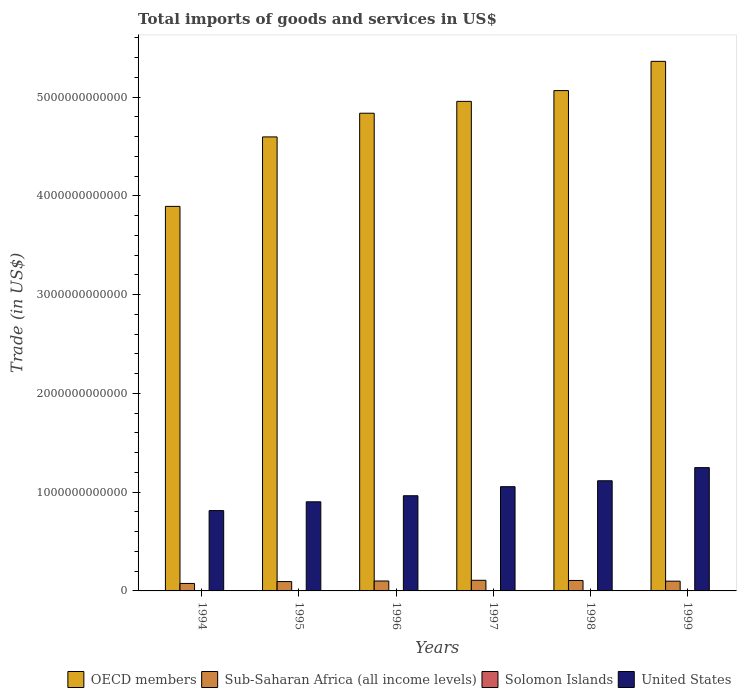Are the number of bars per tick equal to the number of legend labels?
Offer a very short reply. Yes. Are the number of bars on each tick of the X-axis equal?
Your response must be concise. Yes. What is the total imports of goods and services in Sub-Saharan Africa (all income levels) in 1994?
Provide a short and direct response. 7.58e+1. Across all years, what is the maximum total imports of goods and services in Solomon Islands?
Provide a short and direct response. 3.72e+08. Across all years, what is the minimum total imports of goods and services in OECD members?
Offer a very short reply. 3.89e+12. In which year was the total imports of goods and services in Solomon Islands maximum?
Make the answer very short. 1997. What is the total total imports of goods and services in Solomon Islands in the graph?
Make the answer very short. 1.76e+09. What is the difference between the total imports of goods and services in Solomon Islands in 1994 and that in 1997?
Provide a succinct answer. -5.29e+07. What is the difference between the total imports of goods and services in Sub-Saharan Africa (all income levels) in 1998 and the total imports of goods and services in United States in 1996?
Your answer should be very brief. -8.58e+11. What is the average total imports of goods and services in OECD members per year?
Keep it short and to the point. 4.79e+12. In the year 1994, what is the difference between the total imports of goods and services in United States and total imports of goods and services in Sub-Saharan Africa (all income levels)?
Keep it short and to the point. 7.38e+11. What is the ratio of the total imports of goods and services in OECD members in 1998 to that in 1999?
Your answer should be compact. 0.94. Is the difference between the total imports of goods and services in United States in 1994 and 1998 greater than the difference between the total imports of goods and services in Sub-Saharan Africa (all income levels) in 1994 and 1998?
Give a very brief answer. No. What is the difference between the highest and the second highest total imports of goods and services in United States?
Make the answer very short. 1.33e+11. What is the difference between the highest and the lowest total imports of goods and services in Sub-Saharan Africa (all income levels)?
Your response must be concise. 3.19e+1. What does the 3rd bar from the left in 1997 represents?
Make the answer very short. Solomon Islands. Is it the case that in every year, the sum of the total imports of goods and services in OECD members and total imports of goods and services in United States is greater than the total imports of goods and services in Solomon Islands?
Provide a short and direct response. Yes. How many bars are there?
Provide a succinct answer. 24. Are all the bars in the graph horizontal?
Keep it short and to the point. No. What is the difference between two consecutive major ticks on the Y-axis?
Provide a succinct answer. 1.00e+12. Does the graph contain any zero values?
Your response must be concise. No. Does the graph contain grids?
Make the answer very short. No. How many legend labels are there?
Offer a terse response. 4. What is the title of the graph?
Offer a terse response. Total imports of goods and services in US$. What is the label or title of the Y-axis?
Offer a very short reply. Trade (in US$). What is the Trade (in US$) in OECD members in 1994?
Ensure brevity in your answer.  3.89e+12. What is the Trade (in US$) in Sub-Saharan Africa (all income levels) in 1994?
Your answer should be very brief. 7.58e+1. What is the Trade (in US$) in Solomon Islands in 1994?
Your answer should be compact. 3.20e+08. What is the Trade (in US$) of United States in 1994?
Ensure brevity in your answer.  8.13e+11. What is the Trade (in US$) in OECD members in 1995?
Ensure brevity in your answer.  4.60e+12. What is the Trade (in US$) in Sub-Saharan Africa (all income levels) in 1995?
Make the answer very short. 9.47e+1. What is the Trade (in US$) of Solomon Islands in 1995?
Offer a terse response. 3.04e+08. What is the Trade (in US$) in United States in 1995?
Make the answer very short. 9.03e+11. What is the Trade (in US$) of OECD members in 1996?
Give a very brief answer. 4.84e+12. What is the Trade (in US$) of Sub-Saharan Africa (all income levels) in 1996?
Your response must be concise. 1.01e+11. What is the Trade (in US$) in Solomon Islands in 1996?
Offer a very short reply. 3.15e+08. What is the Trade (in US$) of United States in 1996?
Give a very brief answer. 9.64e+11. What is the Trade (in US$) in OECD members in 1997?
Make the answer very short. 4.96e+12. What is the Trade (in US$) in Sub-Saharan Africa (all income levels) in 1997?
Offer a very short reply. 1.08e+11. What is the Trade (in US$) in Solomon Islands in 1997?
Give a very brief answer. 3.72e+08. What is the Trade (in US$) of United States in 1997?
Offer a terse response. 1.06e+12. What is the Trade (in US$) of OECD members in 1998?
Provide a short and direct response. 5.07e+12. What is the Trade (in US$) in Sub-Saharan Africa (all income levels) in 1998?
Offer a very short reply. 1.06e+11. What is the Trade (in US$) in Solomon Islands in 1998?
Your response must be concise. 2.48e+08. What is the Trade (in US$) of United States in 1998?
Your answer should be compact. 1.12e+12. What is the Trade (in US$) of OECD members in 1999?
Provide a short and direct response. 5.36e+12. What is the Trade (in US$) of Sub-Saharan Africa (all income levels) in 1999?
Offer a terse response. 9.89e+1. What is the Trade (in US$) in Solomon Islands in 1999?
Offer a very short reply. 2.03e+08. What is the Trade (in US$) of United States in 1999?
Your response must be concise. 1.25e+12. Across all years, what is the maximum Trade (in US$) of OECD members?
Give a very brief answer. 5.36e+12. Across all years, what is the maximum Trade (in US$) in Sub-Saharan Africa (all income levels)?
Offer a terse response. 1.08e+11. Across all years, what is the maximum Trade (in US$) of Solomon Islands?
Ensure brevity in your answer.  3.72e+08. Across all years, what is the maximum Trade (in US$) in United States?
Offer a terse response. 1.25e+12. Across all years, what is the minimum Trade (in US$) of OECD members?
Your answer should be compact. 3.89e+12. Across all years, what is the minimum Trade (in US$) of Sub-Saharan Africa (all income levels)?
Your answer should be very brief. 7.58e+1. Across all years, what is the minimum Trade (in US$) in Solomon Islands?
Keep it short and to the point. 2.03e+08. Across all years, what is the minimum Trade (in US$) in United States?
Ensure brevity in your answer.  8.13e+11. What is the total Trade (in US$) in OECD members in the graph?
Make the answer very short. 2.87e+13. What is the total Trade (in US$) in Sub-Saharan Africa (all income levels) in the graph?
Give a very brief answer. 5.83e+11. What is the total Trade (in US$) in Solomon Islands in the graph?
Provide a succinct answer. 1.76e+09. What is the total Trade (in US$) of United States in the graph?
Ensure brevity in your answer.  6.10e+12. What is the difference between the Trade (in US$) of OECD members in 1994 and that in 1995?
Your response must be concise. -7.04e+11. What is the difference between the Trade (in US$) of Sub-Saharan Africa (all income levels) in 1994 and that in 1995?
Provide a short and direct response. -1.89e+1. What is the difference between the Trade (in US$) of Solomon Islands in 1994 and that in 1995?
Ensure brevity in your answer.  1.56e+07. What is the difference between the Trade (in US$) of United States in 1994 and that in 1995?
Provide a succinct answer. -8.91e+1. What is the difference between the Trade (in US$) in OECD members in 1994 and that in 1996?
Your answer should be compact. -9.43e+11. What is the difference between the Trade (in US$) in Sub-Saharan Africa (all income levels) in 1994 and that in 1996?
Make the answer very short. -2.47e+1. What is the difference between the Trade (in US$) in Solomon Islands in 1994 and that in 1996?
Offer a very short reply. 4.20e+06. What is the difference between the Trade (in US$) of United States in 1994 and that in 1996?
Give a very brief answer. -1.51e+11. What is the difference between the Trade (in US$) in OECD members in 1994 and that in 1997?
Your answer should be very brief. -1.06e+12. What is the difference between the Trade (in US$) of Sub-Saharan Africa (all income levels) in 1994 and that in 1997?
Offer a terse response. -3.19e+1. What is the difference between the Trade (in US$) of Solomon Islands in 1994 and that in 1997?
Keep it short and to the point. -5.29e+07. What is the difference between the Trade (in US$) in United States in 1994 and that in 1997?
Ensure brevity in your answer.  -2.42e+11. What is the difference between the Trade (in US$) in OECD members in 1994 and that in 1998?
Offer a terse response. -1.17e+12. What is the difference between the Trade (in US$) in Sub-Saharan Africa (all income levels) in 1994 and that in 1998?
Your answer should be very brief. -3.01e+1. What is the difference between the Trade (in US$) in Solomon Islands in 1994 and that in 1998?
Give a very brief answer. 7.14e+07. What is the difference between the Trade (in US$) of United States in 1994 and that in 1998?
Your response must be concise. -3.02e+11. What is the difference between the Trade (in US$) of OECD members in 1994 and that in 1999?
Provide a short and direct response. -1.47e+12. What is the difference between the Trade (in US$) in Sub-Saharan Africa (all income levels) in 1994 and that in 1999?
Ensure brevity in your answer.  -2.31e+1. What is the difference between the Trade (in US$) in Solomon Islands in 1994 and that in 1999?
Your answer should be very brief. 1.17e+08. What is the difference between the Trade (in US$) in United States in 1994 and that in 1999?
Offer a very short reply. -4.35e+11. What is the difference between the Trade (in US$) in OECD members in 1995 and that in 1996?
Keep it short and to the point. -2.40e+11. What is the difference between the Trade (in US$) of Sub-Saharan Africa (all income levels) in 1995 and that in 1996?
Offer a very short reply. -5.80e+09. What is the difference between the Trade (in US$) of Solomon Islands in 1995 and that in 1996?
Provide a short and direct response. -1.14e+07. What is the difference between the Trade (in US$) in United States in 1995 and that in 1996?
Your answer should be compact. -6.14e+1. What is the difference between the Trade (in US$) in OECD members in 1995 and that in 1997?
Keep it short and to the point. -3.60e+11. What is the difference between the Trade (in US$) in Sub-Saharan Africa (all income levels) in 1995 and that in 1997?
Your response must be concise. -1.30e+1. What is the difference between the Trade (in US$) in Solomon Islands in 1995 and that in 1997?
Make the answer very short. -6.85e+07. What is the difference between the Trade (in US$) in United States in 1995 and that in 1997?
Offer a very short reply. -1.53e+11. What is the difference between the Trade (in US$) of OECD members in 1995 and that in 1998?
Your response must be concise. -4.69e+11. What is the difference between the Trade (in US$) of Sub-Saharan Africa (all income levels) in 1995 and that in 1998?
Your response must be concise. -1.12e+1. What is the difference between the Trade (in US$) of Solomon Islands in 1995 and that in 1998?
Keep it short and to the point. 5.58e+07. What is the difference between the Trade (in US$) of United States in 1995 and that in 1998?
Offer a terse response. -2.13e+11. What is the difference between the Trade (in US$) in OECD members in 1995 and that in 1999?
Your answer should be compact. -7.65e+11. What is the difference between the Trade (in US$) of Sub-Saharan Africa (all income levels) in 1995 and that in 1999?
Give a very brief answer. -4.15e+09. What is the difference between the Trade (in US$) in Solomon Islands in 1995 and that in 1999?
Your answer should be very brief. 1.01e+08. What is the difference between the Trade (in US$) in United States in 1995 and that in 1999?
Offer a very short reply. -3.46e+11. What is the difference between the Trade (in US$) in OECD members in 1996 and that in 1997?
Provide a succinct answer. -1.20e+11. What is the difference between the Trade (in US$) of Sub-Saharan Africa (all income levels) in 1996 and that in 1997?
Give a very brief answer. -7.20e+09. What is the difference between the Trade (in US$) in Solomon Islands in 1996 and that in 1997?
Provide a succinct answer. -5.71e+07. What is the difference between the Trade (in US$) in United States in 1996 and that in 1997?
Offer a terse response. -9.18e+1. What is the difference between the Trade (in US$) in OECD members in 1996 and that in 1998?
Your answer should be very brief. -2.29e+11. What is the difference between the Trade (in US$) in Sub-Saharan Africa (all income levels) in 1996 and that in 1998?
Keep it short and to the point. -5.39e+09. What is the difference between the Trade (in US$) of Solomon Islands in 1996 and that in 1998?
Your answer should be very brief. 6.72e+07. What is the difference between the Trade (in US$) of United States in 1996 and that in 1998?
Provide a short and direct response. -1.52e+11. What is the difference between the Trade (in US$) of OECD members in 1996 and that in 1999?
Make the answer very short. -5.25e+11. What is the difference between the Trade (in US$) of Sub-Saharan Africa (all income levels) in 1996 and that in 1999?
Provide a short and direct response. 1.65e+09. What is the difference between the Trade (in US$) in Solomon Islands in 1996 and that in 1999?
Provide a succinct answer. 1.12e+08. What is the difference between the Trade (in US$) of United States in 1996 and that in 1999?
Keep it short and to the point. -2.85e+11. What is the difference between the Trade (in US$) in OECD members in 1997 and that in 1998?
Give a very brief answer. -1.09e+11. What is the difference between the Trade (in US$) in Sub-Saharan Africa (all income levels) in 1997 and that in 1998?
Ensure brevity in your answer.  1.81e+09. What is the difference between the Trade (in US$) in Solomon Islands in 1997 and that in 1998?
Offer a very short reply. 1.24e+08. What is the difference between the Trade (in US$) of United States in 1997 and that in 1998?
Your answer should be very brief. -5.99e+1. What is the difference between the Trade (in US$) in OECD members in 1997 and that in 1999?
Give a very brief answer. -4.05e+11. What is the difference between the Trade (in US$) of Sub-Saharan Africa (all income levels) in 1997 and that in 1999?
Your answer should be very brief. 8.85e+09. What is the difference between the Trade (in US$) in Solomon Islands in 1997 and that in 1999?
Offer a terse response. 1.69e+08. What is the difference between the Trade (in US$) in United States in 1997 and that in 1999?
Offer a very short reply. -1.93e+11. What is the difference between the Trade (in US$) in OECD members in 1998 and that in 1999?
Provide a short and direct response. -2.96e+11. What is the difference between the Trade (in US$) in Sub-Saharan Africa (all income levels) in 1998 and that in 1999?
Your answer should be compact. 7.04e+09. What is the difference between the Trade (in US$) in Solomon Islands in 1998 and that in 1999?
Your response must be concise. 4.51e+07. What is the difference between the Trade (in US$) in United States in 1998 and that in 1999?
Ensure brevity in your answer.  -1.33e+11. What is the difference between the Trade (in US$) in OECD members in 1994 and the Trade (in US$) in Sub-Saharan Africa (all income levels) in 1995?
Your answer should be compact. 3.80e+12. What is the difference between the Trade (in US$) in OECD members in 1994 and the Trade (in US$) in Solomon Islands in 1995?
Offer a terse response. 3.89e+12. What is the difference between the Trade (in US$) in OECD members in 1994 and the Trade (in US$) in United States in 1995?
Provide a succinct answer. 2.99e+12. What is the difference between the Trade (in US$) in Sub-Saharan Africa (all income levels) in 1994 and the Trade (in US$) in Solomon Islands in 1995?
Make the answer very short. 7.55e+1. What is the difference between the Trade (in US$) of Sub-Saharan Africa (all income levels) in 1994 and the Trade (in US$) of United States in 1995?
Your answer should be compact. -8.27e+11. What is the difference between the Trade (in US$) in Solomon Islands in 1994 and the Trade (in US$) in United States in 1995?
Offer a terse response. -9.02e+11. What is the difference between the Trade (in US$) in OECD members in 1994 and the Trade (in US$) in Sub-Saharan Africa (all income levels) in 1996?
Your answer should be compact. 3.79e+12. What is the difference between the Trade (in US$) of OECD members in 1994 and the Trade (in US$) of Solomon Islands in 1996?
Offer a terse response. 3.89e+12. What is the difference between the Trade (in US$) in OECD members in 1994 and the Trade (in US$) in United States in 1996?
Ensure brevity in your answer.  2.93e+12. What is the difference between the Trade (in US$) of Sub-Saharan Africa (all income levels) in 1994 and the Trade (in US$) of Solomon Islands in 1996?
Make the answer very short. 7.55e+1. What is the difference between the Trade (in US$) of Sub-Saharan Africa (all income levels) in 1994 and the Trade (in US$) of United States in 1996?
Make the answer very short. -8.88e+11. What is the difference between the Trade (in US$) in Solomon Islands in 1994 and the Trade (in US$) in United States in 1996?
Ensure brevity in your answer.  -9.64e+11. What is the difference between the Trade (in US$) in OECD members in 1994 and the Trade (in US$) in Sub-Saharan Africa (all income levels) in 1997?
Give a very brief answer. 3.79e+12. What is the difference between the Trade (in US$) in OECD members in 1994 and the Trade (in US$) in Solomon Islands in 1997?
Ensure brevity in your answer.  3.89e+12. What is the difference between the Trade (in US$) of OECD members in 1994 and the Trade (in US$) of United States in 1997?
Your response must be concise. 2.84e+12. What is the difference between the Trade (in US$) in Sub-Saharan Africa (all income levels) in 1994 and the Trade (in US$) in Solomon Islands in 1997?
Give a very brief answer. 7.54e+1. What is the difference between the Trade (in US$) of Sub-Saharan Africa (all income levels) in 1994 and the Trade (in US$) of United States in 1997?
Offer a very short reply. -9.80e+11. What is the difference between the Trade (in US$) of Solomon Islands in 1994 and the Trade (in US$) of United States in 1997?
Give a very brief answer. -1.06e+12. What is the difference between the Trade (in US$) in OECD members in 1994 and the Trade (in US$) in Sub-Saharan Africa (all income levels) in 1998?
Your answer should be compact. 3.79e+12. What is the difference between the Trade (in US$) of OECD members in 1994 and the Trade (in US$) of Solomon Islands in 1998?
Your answer should be very brief. 3.89e+12. What is the difference between the Trade (in US$) in OECD members in 1994 and the Trade (in US$) in United States in 1998?
Your answer should be compact. 2.78e+12. What is the difference between the Trade (in US$) of Sub-Saharan Africa (all income levels) in 1994 and the Trade (in US$) of Solomon Islands in 1998?
Keep it short and to the point. 7.55e+1. What is the difference between the Trade (in US$) of Sub-Saharan Africa (all income levels) in 1994 and the Trade (in US$) of United States in 1998?
Ensure brevity in your answer.  -1.04e+12. What is the difference between the Trade (in US$) of Solomon Islands in 1994 and the Trade (in US$) of United States in 1998?
Your answer should be compact. -1.12e+12. What is the difference between the Trade (in US$) in OECD members in 1994 and the Trade (in US$) in Sub-Saharan Africa (all income levels) in 1999?
Provide a succinct answer. 3.80e+12. What is the difference between the Trade (in US$) of OECD members in 1994 and the Trade (in US$) of Solomon Islands in 1999?
Ensure brevity in your answer.  3.89e+12. What is the difference between the Trade (in US$) of OECD members in 1994 and the Trade (in US$) of United States in 1999?
Provide a short and direct response. 2.65e+12. What is the difference between the Trade (in US$) in Sub-Saharan Africa (all income levels) in 1994 and the Trade (in US$) in Solomon Islands in 1999?
Provide a succinct answer. 7.56e+1. What is the difference between the Trade (in US$) in Sub-Saharan Africa (all income levels) in 1994 and the Trade (in US$) in United States in 1999?
Offer a very short reply. -1.17e+12. What is the difference between the Trade (in US$) in Solomon Islands in 1994 and the Trade (in US$) in United States in 1999?
Your answer should be very brief. -1.25e+12. What is the difference between the Trade (in US$) of OECD members in 1995 and the Trade (in US$) of Sub-Saharan Africa (all income levels) in 1996?
Offer a terse response. 4.50e+12. What is the difference between the Trade (in US$) of OECD members in 1995 and the Trade (in US$) of Solomon Islands in 1996?
Provide a succinct answer. 4.60e+12. What is the difference between the Trade (in US$) of OECD members in 1995 and the Trade (in US$) of United States in 1996?
Offer a very short reply. 3.63e+12. What is the difference between the Trade (in US$) in Sub-Saharan Africa (all income levels) in 1995 and the Trade (in US$) in Solomon Islands in 1996?
Provide a succinct answer. 9.44e+1. What is the difference between the Trade (in US$) of Sub-Saharan Africa (all income levels) in 1995 and the Trade (in US$) of United States in 1996?
Your response must be concise. -8.69e+11. What is the difference between the Trade (in US$) of Solomon Islands in 1995 and the Trade (in US$) of United States in 1996?
Your answer should be compact. -9.64e+11. What is the difference between the Trade (in US$) of OECD members in 1995 and the Trade (in US$) of Sub-Saharan Africa (all income levels) in 1997?
Your answer should be compact. 4.49e+12. What is the difference between the Trade (in US$) in OECD members in 1995 and the Trade (in US$) in Solomon Islands in 1997?
Give a very brief answer. 4.60e+12. What is the difference between the Trade (in US$) of OECD members in 1995 and the Trade (in US$) of United States in 1997?
Provide a succinct answer. 3.54e+12. What is the difference between the Trade (in US$) of Sub-Saharan Africa (all income levels) in 1995 and the Trade (in US$) of Solomon Islands in 1997?
Make the answer very short. 9.43e+1. What is the difference between the Trade (in US$) in Sub-Saharan Africa (all income levels) in 1995 and the Trade (in US$) in United States in 1997?
Provide a short and direct response. -9.61e+11. What is the difference between the Trade (in US$) in Solomon Islands in 1995 and the Trade (in US$) in United States in 1997?
Your answer should be very brief. -1.06e+12. What is the difference between the Trade (in US$) of OECD members in 1995 and the Trade (in US$) of Sub-Saharan Africa (all income levels) in 1998?
Provide a short and direct response. 4.49e+12. What is the difference between the Trade (in US$) in OECD members in 1995 and the Trade (in US$) in Solomon Islands in 1998?
Ensure brevity in your answer.  4.60e+12. What is the difference between the Trade (in US$) in OECD members in 1995 and the Trade (in US$) in United States in 1998?
Your answer should be compact. 3.48e+12. What is the difference between the Trade (in US$) of Sub-Saharan Africa (all income levels) in 1995 and the Trade (in US$) of Solomon Islands in 1998?
Make the answer very short. 9.45e+1. What is the difference between the Trade (in US$) in Sub-Saharan Africa (all income levels) in 1995 and the Trade (in US$) in United States in 1998?
Make the answer very short. -1.02e+12. What is the difference between the Trade (in US$) in Solomon Islands in 1995 and the Trade (in US$) in United States in 1998?
Give a very brief answer. -1.12e+12. What is the difference between the Trade (in US$) in OECD members in 1995 and the Trade (in US$) in Sub-Saharan Africa (all income levels) in 1999?
Give a very brief answer. 4.50e+12. What is the difference between the Trade (in US$) of OECD members in 1995 and the Trade (in US$) of Solomon Islands in 1999?
Give a very brief answer. 4.60e+12. What is the difference between the Trade (in US$) of OECD members in 1995 and the Trade (in US$) of United States in 1999?
Your answer should be compact. 3.35e+12. What is the difference between the Trade (in US$) of Sub-Saharan Africa (all income levels) in 1995 and the Trade (in US$) of Solomon Islands in 1999?
Keep it short and to the point. 9.45e+1. What is the difference between the Trade (in US$) of Sub-Saharan Africa (all income levels) in 1995 and the Trade (in US$) of United States in 1999?
Your answer should be compact. -1.15e+12. What is the difference between the Trade (in US$) in Solomon Islands in 1995 and the Trade (in US$) in United States in 1999?
Keep it short and to the point. -1.25e+12. What is the difference between the Trade (in US$) in OECD members in 1996 and the Trade (in US$) in Sub-Saharan Africa (all income levels) in 1997?
Your answer should be very brief. 4.73e+12. What is the difference between the Trade (in US$) in OECD members in 1996 and the Trade (in US$) in Solomon Islands in 1997?
Your answer should be compact. 4.84e+12. What is the difference between the Trade (in US$) of OECD members in 1996 and the Trade (in US$) of United States in 1997?
Offer a terse response. 3.78e+12. What is the difference between the Trade (in US$) of Sub-Saharan Africa (all income levels) in 1996 and the Trade (in US$) of Solomon Islands in 1997?
Your response must be concise. 1.00e+11. What is the difference between the Trade (in US$) of Sub-Saharan Africa (all income levels) in 1996 and the Trade (in US$) of United States in 1997?
Provide a short and direct response. -9.55e+11. What is the difference between the Trade (in US$) of Solomon Islands in 1996 and the Trade (in US$) of United States in 1997?
Provide a succinct answer. -1.06e+12. What is the difference between the Trade (in US$) in OECD members in 1996 and the Trade (in US$) in Sub-Saharan Africa (all income levels) in 1998?
Offer a very short reply. 4.73e+12. What is the difference between the Trade (in US$) of OECD members in 1996 and the Trade (in US$) of Solomon Islands in 1998?
Offer a very short reply. 4.84e+12. What is the difference between the Trade (in US$) in OECD members in 1996 and the Trade (in US$) in United States in 1998?
Provide a succinct answer. 3.72e+12. What is the difference between the Trade (in US$) in Sub-Saharan Africa (all income levels) in 1996 and the Trade (in US$) in Solomon Islands in 1998?
Offer a very short reply. 1.00e+11. What is the difference between the Trade (in US$) of Sub-Saharan Africa (all income levels) in 1996 and the Trade (in US$) of United States in 1998?
Make the answer very short. -1.02e+12. What is the difference between the Trade (in US$) of Solomon Islands in 1996 and the Trade (in US$) of United States in 1998?
Your response must be concise. -1.12e+12. What is the difference between the Trade (in US$) in OECD members in 1996 and the Trade (in US$) in Sub-Saharan Africa (all income levels) in 1999?
Give a very brief answer. 4.74e+12. What is the difference between the Trade (in US$) of OECD members in 1996 and the Trade (in US$) of Solomon Islands in 1999?
Provide a short and direct response. 4.84e+12. What is the difference between the Trade (in US$) of OECD members in 1996 and the Trade (in US$) of United States in 1999?
Make the answer very short. 3.59e+12. What is the difference between the Trade (in US$) of Sub-Saharan Africa (all income levels) in 1996 and the Trade (in US$) of Solomon Islands in 1999?
Provide a short and direct response. 1.00e+11. What is the difference between the Trade (in US$) of Sub-Saharan Africa (all income levels) in 1996 and the Trade (in US$) of United States in 1999?
Your response must be concise. -1.15e+12. What is the difference between the Trade (in US$) in Solomon Islands in 1996 and the Trade (in US$) in United States in 1999?
Your answer should be compact. -1.25e+12. What is the difference between the Trade (in US$) of OECD members in 1997 and the Trade (in US$) of Sub-Saharan Africa (all income levels) in 1998?
Your answer should be compact. 4.85e+12. What is the difference between the Trade (in US$) of OECD members in 1997 and the Trade (in US$) of Solomon Islands in 1998?
Keep it short and to the point. 4.96e+12. What is the difference between the Trade (in US$) of OECD members in 1997 and the Trade (in US$) of United States in 1998?
Offer a very short reply. 3.84e+12. What is the difference between the Trade (in US$) in Sub-Saharan Africa (all income levels) in 1997 and the Trade (in US$) in Solomon Islands in 1998?
Offer a terse response. 1.07e+11. What is the difference between the Trade (in US$) of Sub-Saharan Africa (all income levels) in 1997 and the Trade (in US$) of United States in 1998?
Your answer should be very brief. -1.01e+12. What is the difference between the Trade (in US$) in Solomon Islands in 1997 and the Trade (in US$) in United States in 1998?
Offer a very short reply. -1.12e+12. What is the difference between the Trade (in US$) of OECD members in 1997 and the Trade (in US$) of Sub-Saharan Africa (all income levels) in 1999?
Offer a very short reply. 4.86e+12. What is the difference between the Trade (in US$) of OECD members in 1997 and the Trade (in US$) of Solomon Islands in 1999?
Offer a very short reply. 4.96e+12. What is the difference between the Trade (in US$) in OECD members in 1997 and the Trade (in US$) in United States in 1999?
Keep it short and to the point. 3.71e+12. What is the difference between the Trade (in US$) of Sub-Saharan Africa (all income levels) in 1997 and the Trade (in US$) of Solomon Islands in 1999?
Your response must be concise. 1.08e+11. What is the difference between the Trade (in US$) of Sub-Saharan Africa (all income levels) in 1997 and the Trade (in US$) of United States in 1999?
Provide a succinct answer. -1.14e+12. What is the difference between the Trade (in US$) of Solomon Islands in 1997 and the Trade (in US$) of United States in 1999?
Make the answer very short. -1.25e+12. What is the difference between the Trade (in US$) of OECD members in 1998 and the Trade (in US$) of Sub-Saharan Africa (all income levels) in 1999?
Provide a short and direct response. 4.97e+12. What is the difference between the Trade (in US$) in OECD members in 1998 and the Trade (in US$) in Solomon Islands in 1999?
Provide a short and direct response. 5.07e+12. What is the difference between the Trade (in US$) of OECD members in 1998 and the Trade (in US$) of United States in 1999?
Give a very brief answer. 3.82e+12. What is the difference between the Trade (in US$) of Sub-Saharan Africa (all income levels) in 1998 and the Trade (in US$) of Solomon Islands in 1999?
Your response must be concise. 1.06e+11. What is the difference between the Trade (in US$) in Sub-Saharan Africa (all income levels) in 1998 and the Trade (in US$) in United States in 1999?
Offer a very short reply. -1.14e+12. What is the difference between the Trade (in US$) of Solomon Islands in 1998 and the Trade (in US$) of United States in 1999?
Provide a short and direct response. -1.25e+12. What is the average Trade (in US$) of OECD members per year?
Your response must be concise. 4.79e+12. What is the average Trade (in US$) of Sub-Saharan Africa (all income levels) per year?
Your answer should be compact. 9.72e+1. What is the average Trade (in US$) in Solomon Islands per year?
Offer a very short reply. 2.94e+08. What is the average Trade (in US$) of United States per year?
Provide a short and direct response. 1.02e+12. In the year 1994, what is the difference between the Trade (in US$) of OECD members and Trade (in US$) of Sub-Saharan Africa (all income levels)?
Provide a succinct answer. 3.82e+12. In the year 1994, what is the difference between the Trade (in US$) in OECD members and Trade (in US$) in Solomon Islands?
Your answer should be compact. 3.89e+12. In the year 1994, what is the difference between the Trade (in US$) of OECD members and Trade (in US$) of United States?
Give a very brief answer. 3.08e+12. In the year 1994, what is the difference between the Trade (in US$) of Sub-Saharan Africa (all income levels) and Trade (in US$) of Solomon Islands?
Provide a succinct answer. 7.55e+1. In the year 1994, what is the difference between the Trade (in US$) of Sub-Saharan Africa (all income levels) and Trade (in US$) of United States?
Make the answer very short. -7.38e+11. In the year 1994, what is the difference between the Trade (in US$) in Solomon Islands and Trade (in US$) in United States?
Ensure brevity in your answer.  -8.13e+11. In the year 1995, what is the difference between the Trade (in US$) in OECD members and Trade (in US$) in Sub-Saharan Africa (all income levels)?
Offer a very short reply. 4.50e+12. In the year 1995, what is the difference between the Trade (in US$) in OECD members and Trade (in US$) in Solomon Islands?
Provide a succinct answer. 4.60e+12. In the year 1995, what is the difference between the Trade (in US$) in OECD members and Trade (in US$) in United States?
Make the answer very short. 3.70e+12. In the year 1995, what is the difference between the Trade (in US$) in Sub-Saharan Africa (all income levels) and Trade (in US$) in Solomon Islands?
Offer a terse response. 9.44e+1. In the year 1995, what is the difference between the Trade (in US$) in Sub-Saharan Africa (all income levels) and Trade (in US$) in United States?
Ensure brevity in your answer.  -8.08e+11. In the year 1995, what is the difference between the Trade (in US$) of Solomon Islands and Trade (in US$) of United States?
Provide a short and direct response. -9.02e+11. In the year 1996, what is the difference between the Trade (in US$) of OECD members and Trade (in US$) of Sub-Saharan Africa (all income levels)?
Your response must be concise. 4.74e+12. In the year 1996, what is the difference between the Trade (in US$) in OECD members and Trade (in US$) in Solomon Islands?
Offer a very short reply. 4.84e+12. In the year 1996, what is the difference between the Trade (in US$) of OECD members and Trade (in US$) of United States?
Offer a very short reply. 3.87e+12. In the year 1996, what is the difference between the Trade (in US$) of Sub-Saharan Africa (all income levels) and Trade (in US$) of Solomon Islands?
Offer a terse response. 1.00e+11. In the year 1996, what is the difference between the Trade (in US$) of Sub-Saharan Africa (all income levels) and Trade (in US$) of United States?
Keep it short and to the point. -8.63e+11. In the year 1996, what is the difference between the Trade (in US$) in Solomon Islands and Trade (in US$) in United States?
Give a very brief answer. -9.64e+11. In the year 1997, what is the difference between the Trade (in US$) in OECD members and Trade (in US$) in Sub-Saharan Africa (all income levels)?
Provide a succinct answer. 4.85e+12. In the year 1997, what is the difference between the Trade (in US$) in OECD members and Trade (in US$) in Solomon Islands?
Provide a succinct answer. 4.96e+12. In the year 1997, what is the difference between the Trade (in US$) in OECD members and Trade (in US$) in United States?
Keep it short and to the point. 3.90e+12. In the year 1997, what is the difference between the Trade (in US$) of Sub-Saharan Africa (all income levels) and Trade (in US$) of Solomon Islands?
Ensure brevity in your answer.  1.07e+11. In the year 1997, what is the difference between the Trade (in US$) of Sub-Saharan Africa (all income levels) and Trade (in US$) of United States?
Your answer should be compact. -9.48e+11. In the year 1997, what is the difference between the Trade (in US$) of Solomon Islands and Trade (in US$) of United States?
Your answer should be very brief. -1.06e+12. In the year 1998, what is the difference between the Trade (in US$) of OECD members and Trade (in US$) of Sub-Saharan Africa (all income levels)?
Provide a short and direct response. 4.96e+12. In the year 1998, what is the difference between the Trade (in US$) of OECD members and Trade (in US$) of Solomon Islands?
Your answer should be compact. 5.07e+12. In the year 1998, what is the difference between the Trade (in US$) of OECD members and Trade (in US$) of United States?
Your answer should be compact. 3.95e+12. In the year 1998, what is the difference between the Trade (in US$) of Sub-Saharan Africa (all income levels) and Trade (in US$) of Solomon Islands?
Provide a succinct answer. 1.06e+11. In the year 1998, what is the difference between the Trade (in US$) in Sub-Saharan Africa (all income levels) and Trade (in US$) in United States?
Keep it short and to the point. -1.01e+12. In the year 1998, what is the difference between the Trade (in US$) in Solomon Islands and Trade (in US$) in United States?
Provide a succinct answer. -1.12e+12. In the year 1999, what is the difference between the Trade (in US$) of OECD members and Trade (in US$) of Sub-Saharan Africa (all income levels)?
Provide a short and direct response. 5.26e+12. In the year 1999, what is the difference between the Trade (in US$) of OECD members and Trade (in US$) of Solomon Islands?
Keep it short and to the point. 5.36e+12. In the year 1999, what is the difference between the Trade (in US$) in OECD members and Trade (in US$) in United States?
Your answer should be very brief. 4.11e+12. In the year 1999, what is the difference between the Trade (in US$) in Sub-Saharan Africa (all income levels) and Trade (in US$) in Solomon Islands?
Your answer should be very brief. 9.87e+1. In the year 1999, what is the difference between the Trade (in US$) in Sub-Saharan Africa (all income levels) and Trade (in US$) in United States?
Provide a succinct answer. -1.15e+12. In the year 1999, what is the difference between the Trade (in US$) of Solomon Islands and Trade (in US$) of United States?
Your response must be concise. -1.25e+12. What is the ratio of the Trade (in US$) in OECD members in 1994 to that in 1995?
Make the answer very short. 0.85. What is the ratio of the Trade (in US$) in Sub-Saharan Africa (all income levels) in 1994 to that in 1995?
Ensure brevity in your answer.  0.8. What is the ratio of the Trade (in US$) of Solomon Islands in 1994 to that in 1995?
Give a very brief answer. 1.05. What is the ratio of the Trade (in US$) of United States in 1994 to that in 1995?
Your answer should be compact. 0.9. What is the ratio of the Trade (in US$) in OECD members in 1994 to that in 1996?
Ensure brevity in your answer.  0.81. What is the ratio of the Trade (in US$) in Sub-Saharan Africa (all income levels) in 1994 to that in 1996?
Give a very brief answer. 0.75. What is the ratio of the Trade (in US$) in Solomon Islands in 1994 to that in 1996?
Your answer should be very brief. 1.01. What is the ratio of the Trade (in US$) of United States in 1994 to that in 1996?
Provide a succinct answer. 0.84. What is the ratio of the Trade (in US$) in OECD members in 1994 to that in 1997?
Your answer should be very brief. 0.79. What is the ratio of the Trade (in US$) in Sub-Saharan Africa (all income levels) in 1994 to that in 1997?
Provide a short and direct response. 0.7. What is the ratio of the Trade (in US$) in Solomon Islands in 1994 to that in 1997?
Your answer should be compact. 0.86. What is the ratio of the Trade (in US$) of United States in 1994 to that in 1997?
Offer a terse response. 0.77. What is the ratio of the Trade (in US$) of OECD members in 1994 to that in 1998?
Your response must be concise. 0.77. What is the ratio of the Trade (in US$) of Sub-Saharan Africa (all income levels) in 1994 to that in 1998?
Provide a short and direct response. 0.72. What is the ratio of the Trade (in US$) of Solomon Islands in 1994 to that in 1998?
Provide a succinct answer. 1.29. What is the ratio of the Trade (in US$) of United States in 1994 to that in 1998?
Ensure brevity in your answer.  0.73. What is the ratio of the Trade (in US$) of OECD members in 1994 to that in 1999?
Offer a very short reply. 0.73. What is the ratio of the Trade (in US$) in Sub-Saharan Africa (all income levels) in 1994 to that in 1999?
Provide a succinct answer. 0.77. What is the ratio of the Trade (in US$) of Solomon Islands in 1994 to that in 1999?
Make the answer very short. 1.57. What is the ratio of the Trade (in US$) of United States in 1994 to that in 1999?
Offer a terse response. 0.65. What is the ratio of the Trade (in US$) in OECD members in 1995 to that in 1996?
Offer a very short reply. 0.95. What is the ratio of the Trade (in US$) of Sub-Saharan Africa (all income levels) in 1995 to that in 1996?
Make the answer very short. 0.94. What is the ratio of the Trade (in US$) in Solomon Islands in 1995 to that in 1996?
Your answer should be compact. 0.96. What is the ratio of the Trade (in US$) of United States in 1995 to that in 1996?
Ensure brevity in your answer.  0.94. What is the ratio of the Trade (in US$) of OECD members in 1995 to that in 1997?
Ensure brevity in your answer.  0.93. What is the ratio of the Trade (in US$) in Sub-Saharan Africa (all income levels) in 1995 to that in 1997?
Offer a very short reply. 0.88. What is the ratio of the Trade (in US$) in Solomon Islands in 1995 to that in 1997?
Give a very brief answer. 0.82. What is the ratio of the Trade (in US$) of United States in 1995 to that in 1997?
Provide a succinct answer. 0.85. What is the ratio of the Trade (in US$) of OECD members in 1995 to that in 1998?
Offer a very short reply. 0.91. What is the ratio of the Trade (in US$) of Sub-Saharan Africa (all income levels) in 1995 to that in 1998?
Offer a very short reply. 0.89. What is the ratio of the Trade (in US$) of Solomon Islands in 1995 to that in 1998?
Keep it short and to the point. 1.22. What is the ratio of the Trade (in US$) of United States in 1995 to that in 1998?
Your response must be concise. 0.81. What is the ratio of the Trade (in US$) in OECD members in 1995 to that in 1999?
Provide a succinct answer. 0.86. What is the ratio of the Trade (in US$) of Sub-Saharan Africa (all income levels) in 1995 to that in 1999?
Your response must be concise. 0.96. What is the ratio of the Trade (in US$) of Solomon Islands in 1995 to that in 1999?
Your response must be concise. 1.5. What is the ratio of the Trade (in US$) of United States in 1995 to that in 1999?
Provide a short and direct response. 0.72. What is the ratio of the Trade (in US$) in OECD members in 1996 to that in 1997?
Give a very brief answer. 0.98. What is the ratio of the Trade (in US$) in Sub-Saharan Africa (all income levels) in 1996 to that in 1997?
Provide a succinct answer. 0.93. What is the ratio of the Trade (in US$) in Solomon Islands in 1996 to that in 1997?
Your response must be concise. 0.85. What is the ratio of the Trade (in US$) in United States in 1996 to that in 1997?
Keep it short and to the point. 0.91. What is the ratio of the Trade (in US$) in OECD members in 1996 to that in 1998?
Your answer should be very brief. 0.95. What is the ratio of the Trade (in US$) of Sub-Saharan Africa (all income levels) in 1996 to that in 1998?
Give a very brief answer. 0.95. What is the ratio of the Trade (in US$) of Solomon Islands in 1996 to that in 1998?
Offer a terse response. 1.27. What is the ratio of the Trade (in US$) of United States in 1996 to that in 1998?
Keep it short and to the point. 0.86. What is the ratio of the Trade (in US$) of OECD members in 1996 to that in 1999?
Give a very brief answer. 0.9. What is the ratio of the Trade (in US$) in Sub-Saharan Africa (all income levels) in 1996 to that in 1999?
Make the answer very short. 1.02. What is the ratio of the Trade (in US$) of Solomon Islands in 1996 to that in 1999?
Give a very brief answer. 1.55. What is the ratio of the Trade (in US$) of United States in 1996 to that in 1999?
Provide a succinct answer. 0.77. What is the ratio of the Trade (in US$) of OECD members in 1997 to that in 1998?
Your response must be concise. 0.98. What is the ratio of the Trade (in US$) in Sub-Saharan Africa (all income levels) in 1997 to that in 1998?
Provide a succinct answer. 1.02. What is the ratio of the Trade (in US$) in Solomon Islands in 1997 to that in 1998?
Make the answer very short. 1.5. What is the ratio of the Trade (in US$) of United States in 1997 to that in 1998?
Offer a terse response. 0.95. What is the ratio of the Trade (in US$) of OECD members in 1997 to that in 1999?
Ensure brevity in your answer.  0.92. What is the ratio of the Trade (in US$) of Sub-Saharan Africa (all income levels) in 1997 to that in 1999?
Your answer should be compact. 1.09. What is the ratio of the Trade (in US$) in Solomon Islands in 1997 to that in 1999?
Keep it short and to the point. 1.83. What is the ratio of the Trade (in US$) of United States in 1997 to that in 1999?
Your response must be concise. 0.85. What is the ratio of the Trade (in US$) in OECD members in 1998 to that in 1999?
Make the answer very short. 0.94. What is the ratio of the Trade (in US$) of Sub-Saharan Africa (all income levels) in 1998 to that in 1999?
Keep it short and to the point. 1.07. What is the ratio of the Trade (in US$) of Solomon Islands in 1998 to that in 1999?
Ensure brevity in your answer.  1.22. What is the ratio of the Trade (in US$) of United States in 1998 to that in 1999?
Ensure brevity in your answer.  0.89. What is the difference between the highest and the second highest Trade (in US$) in OECD members?
Your answer should be compact. 2.96e+11. What is the difference between the highest and the second highest Trade (in US$) of Sub-Saharan Africa (all income levels)?
Your response must be concise. 1.81e+09. What is the difference between the highest and the second highest Trade (in US$) in Solomon Islands?
Ensure brevity in your answer.  5.29e+07. What is the difference between the highest and the second highest Trade (in US$) in United States?
Keep it short and to the point. 1.33e+11. What is the difference between the highest and the lowest Trade (in US$) of OECD members?
Provide a short and direct response. 1.47e+12. What is the difference between the highest and the lowest Trade (in US$) of Sub-Saharan Africa (all income levels)?
Ensure brevity in your answer.  3.19e+1. What is the difference between the highest and the lowest Trade (in US$) in Solomon Islands?
Your answer should be very brief. 1.69e+08. What is the difference between the highest and the lowest Trade (in US$) of United States?
Offer a terse response. 4.35e+11. 